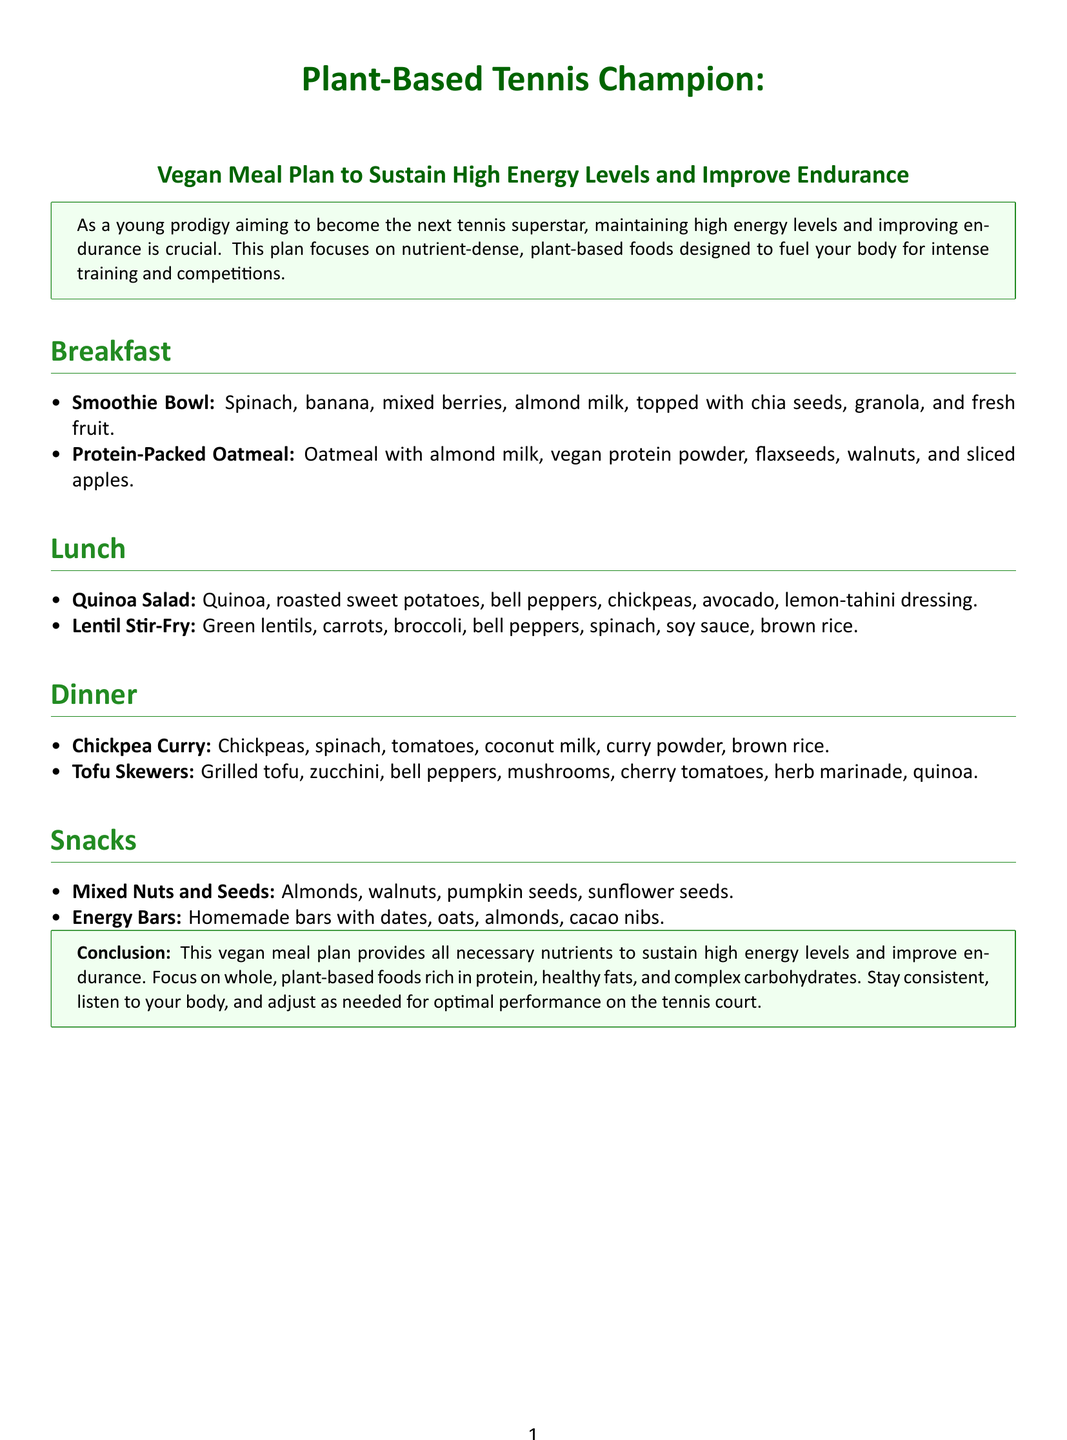What is the title of the document? The title of the document is presented prominently at the top, which is "Plant-Based Tennis Champion."
Answer: Plant-Based Tennis Champion What is the focus of the vegan meal plan? The plan focuses on providing high energy levels and improving endurance for tennis players by highlighting nutrient-dense foods.
Answer: High energy levels and improving endurance Name one ingredient in the smoothie bowl. The smoothie bowl includes multiple ingredients, one of which is spinach, among others mentioned.
Answer: Spinach What type of nuts are included in the snacks? The document mentions mixed nuts, including almonds and walnuts specifically as part of the snack options.
Answer: Almonds How is the chickpea curry served? The chickpea curry is paired with a carbohydrate source, which is brown rice, as mentioned in the dinner section.
Answer: Brown rice What is a key component of the protein-packed oatmeal? The oatmeal includes a specific ingredient to boost protein content, which is vegan protein powder.
Answer: Vegan protein powder Which type of legumes is used in the lunch options? The lunch includes multiple items centered around legumes, with one example being chickpeas in the quinoa salad.
Answer: Chickpeas How are the tofu skewers prepared? The tofu skewers are cooked using a method that involves grilling, which is specified in the dinner section.
Answer: Grilled 